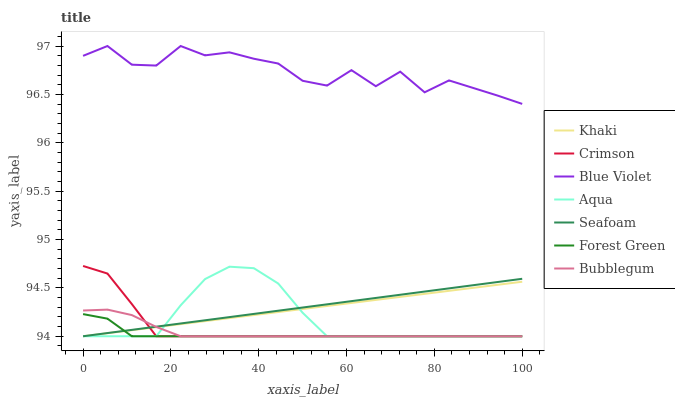Does Forest Green have the minimum area under the curve?
Answer yes or no. Yes. Does Blue Violet have the maximum area under the curve?
Answer yes or no. Yes. Does Aqua have the minimum area under the curve?
Answer yes or no. No. Does Aqua have the maximum area under the curve?
Answer yes or no. No. Is Seafoam the smoothest?
Answer yes or no. Yes. Is Blue Violet the roughest?
Answer yes or no. Yes. Is Aqua the smoothest?
Answer yes or no. No. Is Aqua the roughest?
Answer yes or no. No. Does Blue Violet have the lowest value?
Answer yes or no. No. Does Blue Violet have the highest value?
Answer yes or no. Yes. Does Aqua have the highest value?
Answer yes or no. No. Is Seafoam less than Blue Violet?
Answer yes or no. Yes. Is Blue Violet greater than Khaki?
Answer yes or no. Yes. Does Seafoam intersect Blue Violet?
Answer yes or no. No. 